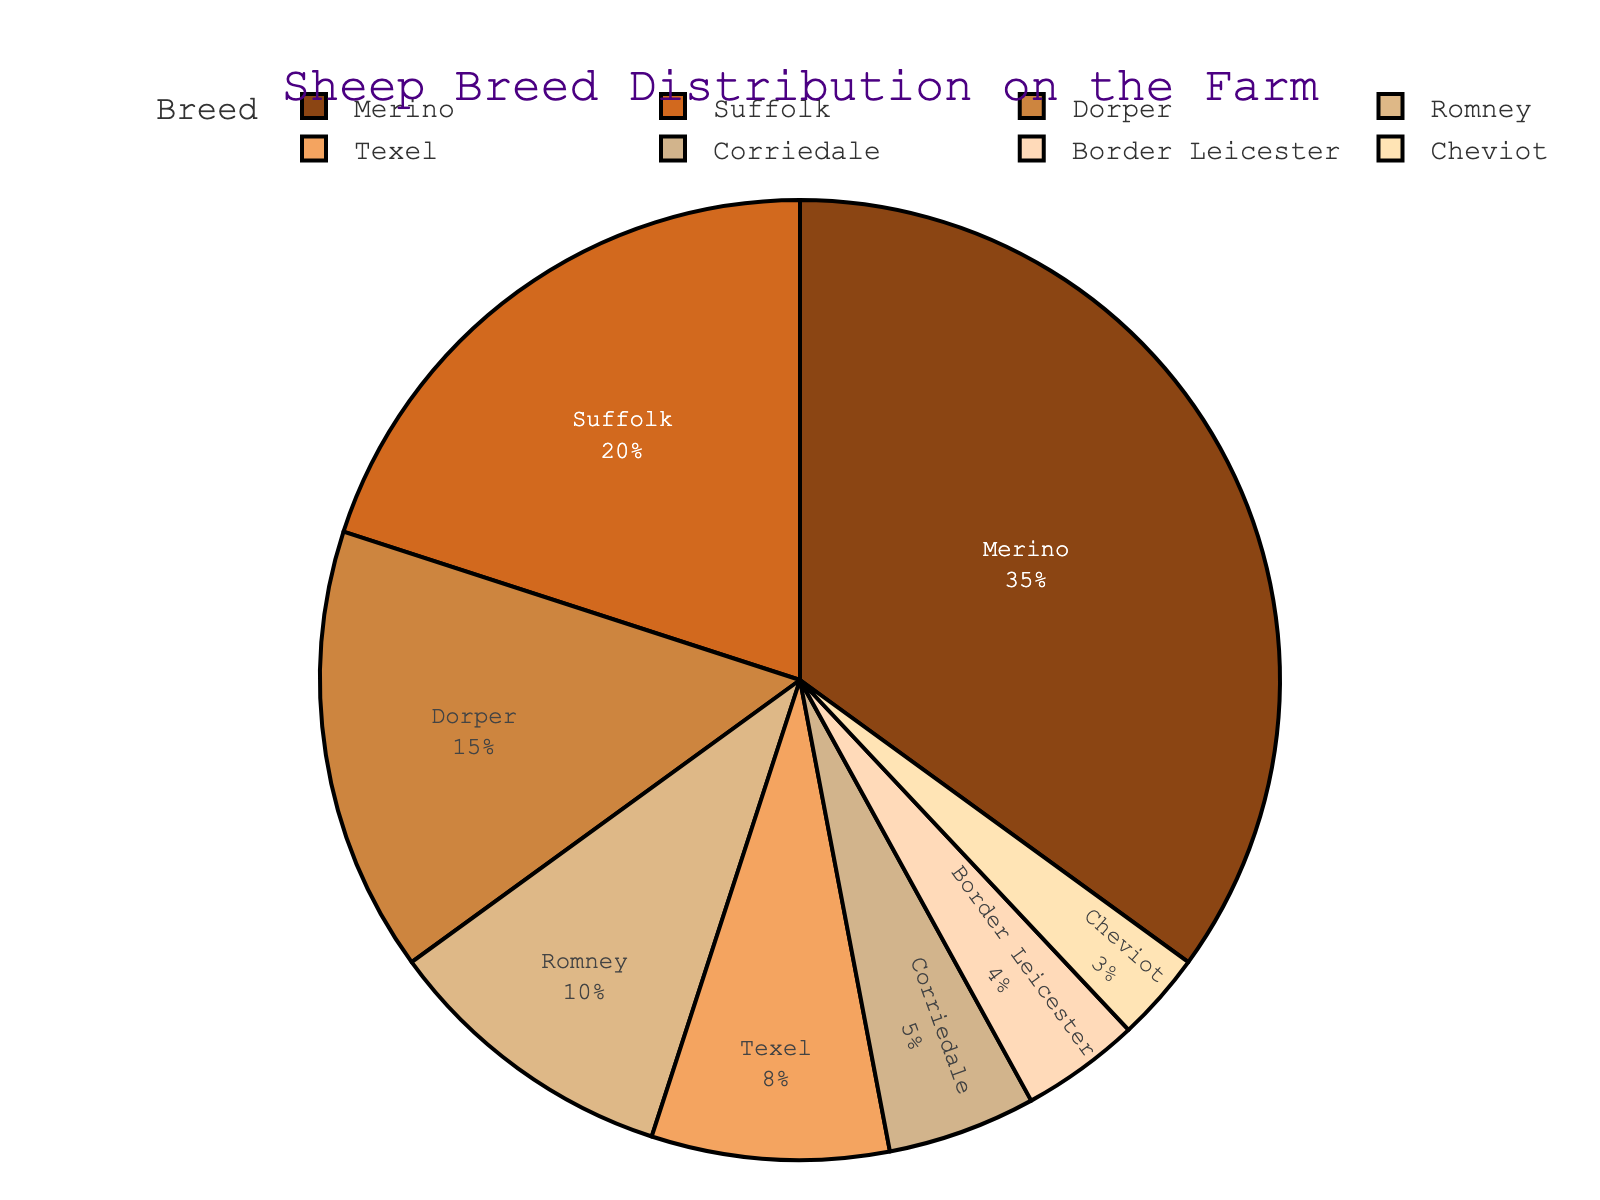Which sheep breed has the largest percentage on the farm? The pie chart indicates the percentage of each sheep breed. The largest segment belongs to the Merino breed, which is 35%.
Answer: Merino Which breeds make up at least 20% of the farm's sheep population combined? We need to identify breeds where the combined percentage reaches at least 20%. Merino alone is 35%, and Suffolk is 20%.
Answer: Merino, Suffolk How much larger is the percentage of Merino sheep compared to Dorper sheep? Merino has 35% and Dorper has 15%. The difference is 35% - 15%.
Answer: 20% What is the combined percentage of Cheviot and Border Leicester breeds? Adding the percentages of Cheviot (3%) and Border Leicester (4%) gives 3% + 4%.
Answer: 7% Which breed has the smallest percentage on the farm? The smallest segment in the pie chart corresponds to the Cheviot breed at 3%.
Answer: Cheviot How does the sum of Texel and Corriedale percentages compare to the percentage of Suffolk sheep? Texel has 8% and Corriedale has 5%, their sum is 8% + 5% = 13%. Suffolk has 20%. Comparing, 13% is less than 20%.
Answer: Less than How many breeds have a percentage greater than 10%? Identify the segments with percentages greater than 10%: Merino (35%), Suffolk (20%), Dorper (15%), Romney (10%). There are 4 breeds.
Answer: 4 breeds What's the combined percentage of all breeds except Merino? Sum the percentages of Suffolk (20%), Dorper (15%), Romney (10%), Texel (8%), Corriedale (5%), Border Leicester (4%), Cheviot (3%) which is 20% + 15% + 10% + 8% + 5% + 4% + 3% = 65%.
Answer: 65% Are there more Romney or Suffolk sheep? Compare percentages: Romney has 10%, Suffolk has 20%. Suffolk is greater.
Answer: Suffolk What is the average percentage of the Romney, Texel, and Corriedale breeds? Adding percentages of Romney (10%), Texel (8%), and Corriedale (5%): 10% + 8% + 5% = 23%. The average is 23% / 3 = 7.67%.
Answer: 7.67% 